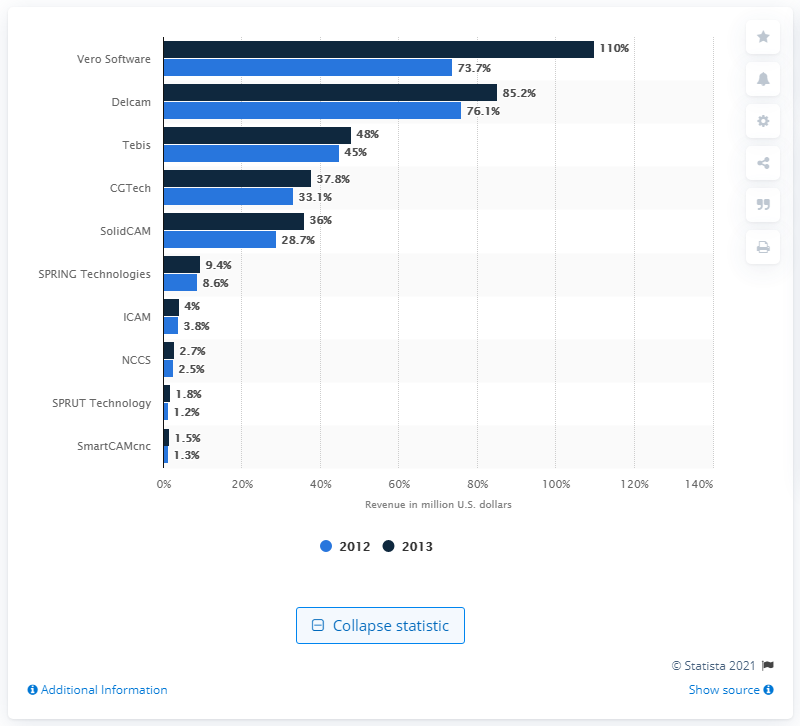Draw attention to some important aspects in this diagram. In 2013, Vero Software generated $110 million in revenue. 